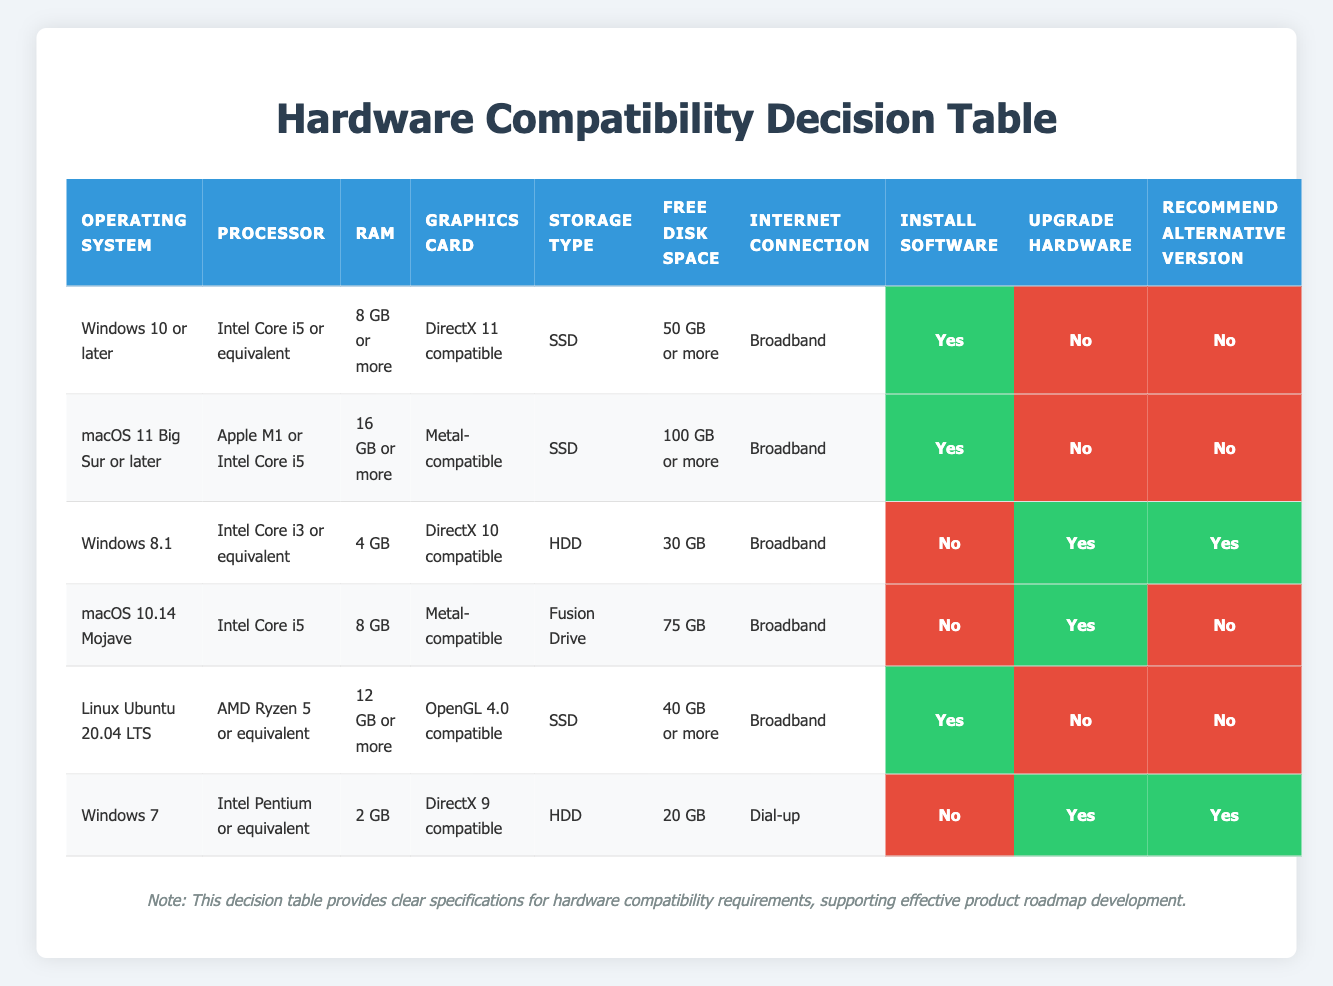What are the minimum RAM requirements for installing the software on Windows 8.1? According to the table, the row for Windows 8.1 specifies a minimum RAM requirement of "4 GB."
Answer: 4 GB Can the software be installed on macOS 10.14 Mojave? The row for macOS 10.14 Mojave indicates "Install Software" as false, meaning the software cannot be installed on this OS version.
Answer: No Which operating system has the highest free disk space requirement? The macOS 11 Big Sur or later indicates a requirement of "100 GB or more," which is higher than all other listed operating systems.
Answer: macOS 11 Big Sur or later Is an internet connection required for installing the software on Linux Ubuntu 20.04 LTS? In the table, the entry for Linux Ubuntu 20.04 LTS states that a "Broadband" internet connection is needed for installation, which confirms it is required.
Answer: Yes If a user's device has 16 GB of RAM and an Intel Core i3 processor with a DirectX 10 compatible graphics card, what should they do? Based on the row for Windows 8.1, despite having enough RAM, the user does not meet the processor (Intel Core i3 is below Intel Core i5) and graphics card requirements (DirectX 10 isn't sufficient). Therefore, they need to upgrade hardware and will be recommended an alternative version.
Answer: Upgrade Hardware and Recommend Alternative Version What is the relationship between the operating systems that can install software and those that require hardware upgrades? Checking the table, the operating systems that can install software (Windows 10 or later, macOS 11 Big Sur, and Linux Ubuntu 20.04 LTS) do not require hardware upgrades, while those that require upgrades (Windows 8.1 and Windows 7) cannot install the software. This indicates that all capable systems avoid the need for hardware upgrades.
Answer: All OS capable of installation require no hardware upgrades Which graphics card compatibility is common for systems that can install the software? The systems that can install the software require graphics cards that are DirectX 11 compatible (Windows 10 or later), Metal-compatible (macOS 11 Big Sur), and OpenGL 4.0 compatible (Linux Ubuntu 20.04 LTS). Thus, compatibility depends on the software version and its specific requirements.
Answer: Varies by OS What is the total number of recommendations for alternative versions based on the table? There are two instances where "Recommend Alternative Version" is true, specifically for Windows 8.1 and Windows 7. Therefore, the total count is 2.
Answer: 2 How many operating systems listed allow installation of the software? The row entries indicate that there are three operating systems that allow software installation: Windows 10 or later, macOS 11 Big Sur or later, and Linux Ubuntu 20.04 LTS, totaling three.
Answer: 3 